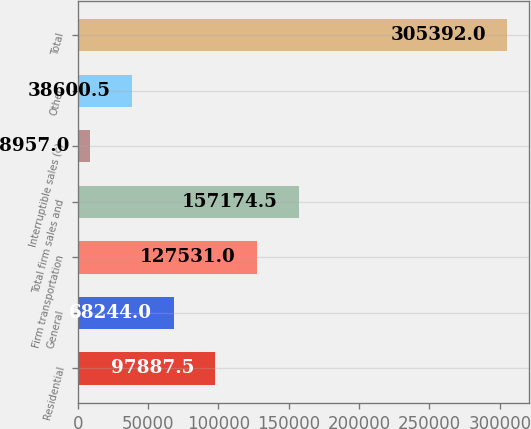Convert chart to OTSL. <chart><loc_0><loc_0><loc_500><loc_500><bar_chart><fcel>Residential<fcel>General<fcel>Firm transportation<fcel>Total firm sales and<fcel>Interruptible sales (c)<fcel>Other<fcel>Total<nl><fcel>97887.5<fcel>68244<fcel>127531<fcel>157174<fcel>8957<fcel>38600.5<fcel>305392<nl></chart> 